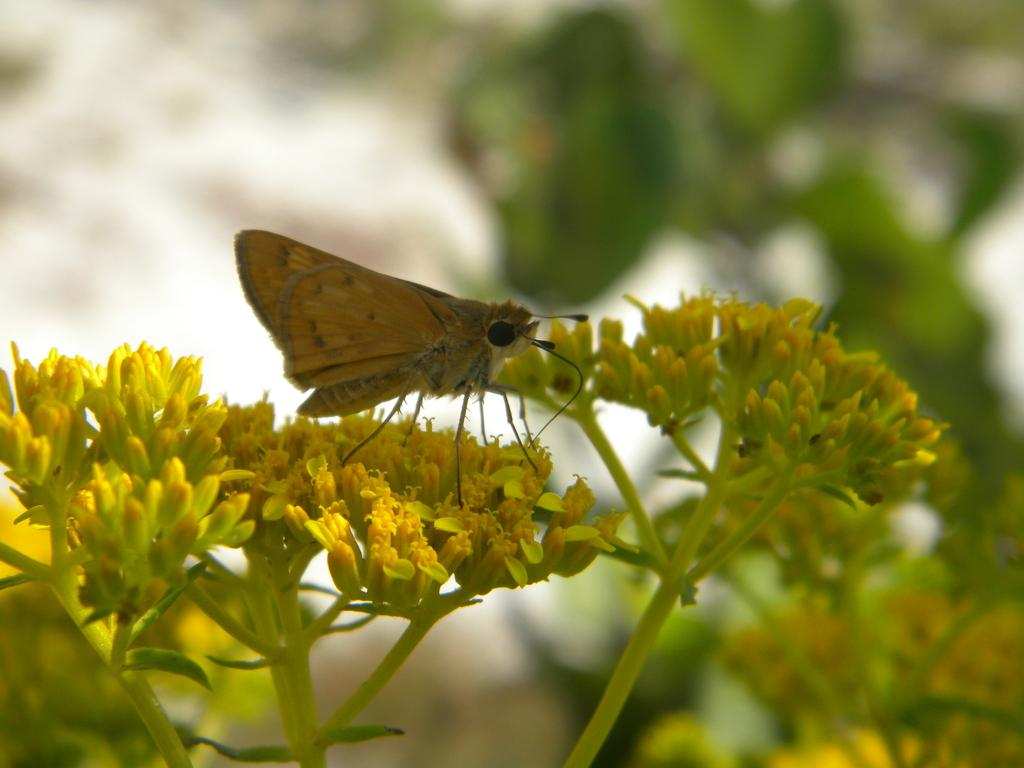What type of flowers can be seen in the image? There are yellow color flowers in the image. Is there any other living organism present on the flowers? Yes, there is a butterfly on one of the flowers. What is the color of the butterfly? The butterfly is yellow in color. What can be seen in the background of the image? There are trees visible in the background of the image. What hobbies does the pet in the image enjoy? There is no pet present in the image, so it's not possible to determine their hobbies. 